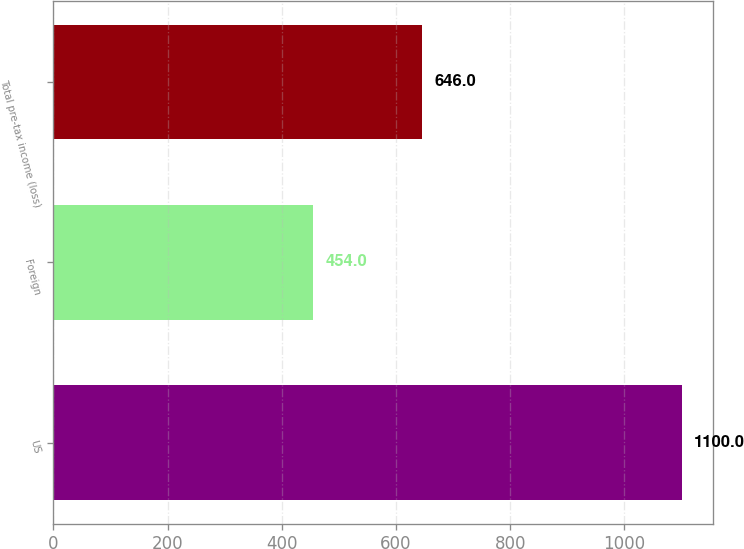Convert chart to OTSL. <chart><loc_0><loc_0><loc_500><loc_500><bar_chart><fcel>US<fcel>Foreign<fcel>Total pre-tax income (loss)<nl><fcel>1100<fcel>454<fcel>646<nl></chart> 